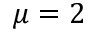Convert formula to latex. <formula><loc_0><loc_0><loc_500><loc_500>\mu = 2</formula> 